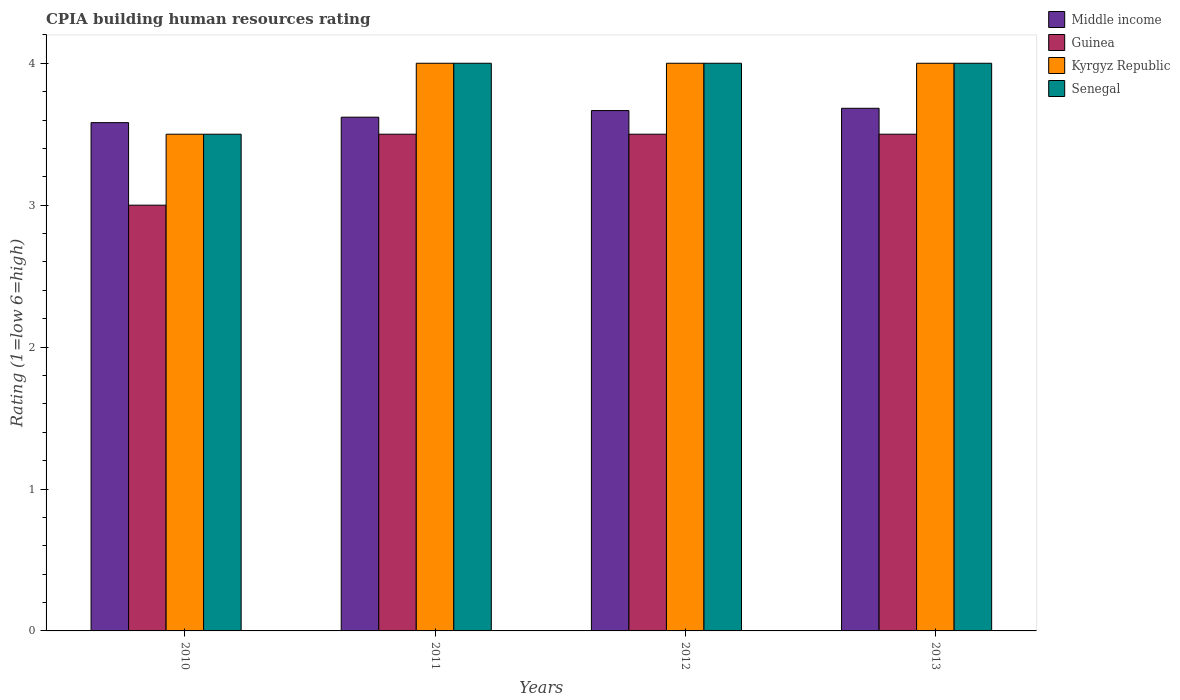How many different coloured bars are there?
Ensure brevity in your answer.  4. How many groups of bars are there?
Ensure brevity in your answer.  4. Are the number of bars on each tick of the X-axis equal?
Keep it short and to the point. Yes. How many bars are there on the 1st tick from the left?
Provide a short and direct response. 4. How many bars are there on the 2nd tick from the right?
Offer a terse response. 4. In how many cases, is the number of bars for a given year not equal to the number of legend labels?
Provide a succinct answer. 0. What is the CPIA rating in Senegal in 2011?
Offer a terse response. 4. Across all years, what is the minimum CPIA rating in Middle income?
Your response must be concise. 3.58. In which year was the CPIA rating in Middle income maximum?
Your answer should be very brief. 2013. In which year was the CPIA rating in Kyrgyz Republic minimum?
Give a very brief answer. 2010. What is the total CPIA rating in Middle income in the graph?
Provide a succinct answer. 14.55. What is the difference between the CPIA rating in Senegal in 2011 and the CPIA rating in Guinea in 2010?
Your answer should be very brief. 1. What is the average CPIA rating in Middle income per year?
Give a very brief answer. 3.64. In the year 2013, what is the difference between the CPIA rating in Middle income and CPIA rating in Guinea?
Make the answer very short. 0.18. In how many years, is the CPIA rating in Middle income greater than 2.2?
Your answer should be very brief. 4. Is the CPIA rating in Kyrgyz Republic in 2010 less than that in 2011?
Keep it short and to the point. Yes. Is the difference between the CPIA rating in Middle income in 2010 and 2011 greater than the difference between the CPIA rating in Guinea in 2010 and 2011?
Offer a terse response. Yes. What is the difference between the highest and the lowest CPIA rating in Senegal?
Provide a short and direct response. 0.5. In how many years, is the CPIA rating in Kyrgyz Republic greater than the average CPIA rating in Kyrgyz Republic taken over all years?
Your response must be concise. 3. What does the 4th bar from the left in 2010 represents?
Offer a terse response. Senegal. Is it the case that in every year, the sum of the CPIA rating in Middle income and CPIA rating in Kyrgyz Republic is greater than the CPIA rating in Guinea?
Offer a very short reply. Yes. Are all the bars in the graph horizontal?
Your answer should be very brief. No. How many years are there in the graph?
Offer a very short reply. 4. What is the difference between two consecutive major ticks on the Y-axis?
Your response must be concise. 1. How many legend labels are there?
Provide a short and direct response. 4. How are the legend labels stacked?
Your answer should be very brief. Vertical. What is the title of the graph?
Provide a short and direct response. CPIA building human resources rating. Does "Egypt, Arab Rep." appear as one of the legend labels in the graph?
Keep it short and to the point. No. What is the label or title of the X-axis?
Offer a terse response. Years. What is the Rating (1=low 6=high) in Middle income in 2010?
Your answer should be very brief. 3.58. What is the Rating (1=low 6=high) of Guinea in 2010?
Your answer should be compact. 3. What is the Rating (1=low 6=high) of Senegal in 2010?
Provide a succinct answer. 3.5. What is the Rating (1=low 6=high) in Middle income in 2011?
Offer a terse response. 3.62. What is the Rating (1=low 6=high) of Guinea in 2011?
Ensure brevity in your answer.  3.5. What is the Rating (1=low 6=high) of Kyrgyz Republic in 2011?
Your answer should be very brief. 4. What is the Rating (1=low 6=high) in Senegal in 2011?
Your response must be concise. 4. What is the Rating (1=low 6=high) of Middle income in 2012?
Your answer should be compact. 3.67. What is the Rating (1=low 6=high) of Guinea in 2012?
Your answer should be very brief. 3.5. What is the Rating (1=low 6=high) in Kyrgyz Republic in 2012?
Ensure brevity in your answer.  4. What is the Rating (1=low 6=high) in Middle income in 2013?
Give a very brief answer. 3.68. What is the Rating (1=low 6=high) in Guinea in 2013?
Ensure brevity in your answer.  3.5. What is the Rating (1=low 6=high) of Kyrgyz Republic in 2013?
Provide a short and direct response. 4. Across all years, what is the maximum Rating (1=low 6=high) of Middle income?
Make the answer very short. 3.68. Across all years, what is the maximum Rating (1=low 6=high) in Guinea?
Your response must be concise. 3.5. Across all years, what is the maximum Rating (1=low 6=high) of Senegal?
Provide a succinct answer. 4. Across all years, what is the minimum Rating (1=low 6=high) in Middle income?
Offer a terse response. 3.58. Across all years, what is the minimum Rating (1=low 6=high) in Kyrgyz Republic?
Make the answer very short. 3.5. Across all years, what is the minimum Rating (1=low 6=high) of Senegal?
Your answer should be compact. 3.5. What is the total Rating (1=low 6=high) in Middle income in the graph?
Make the answer very short. 14.55. What is the total Rating (1=low 6=high) in Senegal in the graph?
Your response must be concise. 15.5. What is the difference between the Rating (1=low 6=high) of Middle income in 2010 and that in 2011?
Make the answer very short. -0.04. What is the difference between the Rating (1=low 6=high) of Guinea in 2010 and that in 2011?
Keep it short and to the point. -0.5. What is the difference between the Rating (1=low 6=high) of Kyrgyz Republic in 2010 and that in 2011?
Keep it short and to the point. -0.5. What is the difference between the Rating (1=low 6=high) in Senegal in 2010 and that in 2011?
Offer a very short reply. -0.5. What is the difference between the Rating (1=low 6=high) in Middle income in 2010 and that in 2012?
Ensure brevity in your answer.  -0.09. What is the difference between the Rating (1=low 6=high) of Kyrgyz Republic in 2010 and that in 2012?
Ensure brevity in your answer.  -0.5. What is the difference between the Rating (1=low 6=high) in Middle income in 2010 and that in 2013?
Provide a short and direct response. -0.1. What is the difference between the Rating (1=low 6=high) in Kyrgyz Republic in 2010 and that in 2013?
Make the answer very short. -0.5. What is the difference between the Rating (1=low 6=high) in Senegal in 2010 and that in 2013?
Offer a terse response. -0.5. What is the difference between the Rating (1=low 6=high) of Middle income in 2011 and that in 2012?
Offer a very short reply. -0.05. What is the difference between the Rating (1=low 6=high) of Kyrgyz Republic in 2011 and that in 2012?
Make the answer very short. 0. What is the difference between the Rating (1=low 6=high) in Middle income in 2011 and that in 2013?
Make the answer very short. -0.06. What is the difference between the Rating (1=low 6=high) of Kyrgyz Republic in 2011 and that in 2013?
Ensure brevity in your answer.  0. What is the difference between the Rating (1=low 6=high) in Senegal in 2011 and that in 2013?
Keep it short and to the point. 0. What is the difference between the Rating (1=low 6=high) of Middle income in 2012 and that in 2013?
Keep it short and to the point. -0.02. What is the difference between the Rating (1=low 6=high) of Guinea in 2012 and that in 2013?
Your answer should be very brief. 0. What is the difference between the Rating (1=low 6=high) in Middle income in 2010 and the Rating (1=low 6=high) in Guinea in 2011?
Your response must be concise. 0.08. What is the difference between the Rating (1=low 6=high) in Middle income in 2010 and the Rating (1=low 6=high) in Kyrgyz Republic in 2011?
Your answer should be very brief. -0.42. What is the difference between the Rating (1=low 6=high) in Middle income in 2010 and the Rating (1=low 6=high) in Senegal in 2011?
Keep it short and to the point. -0.42. What is the difference between the Rating (1=low 6=high) of Guinea in 2010 and the Rating (1=low 6=high) of Senegal in 2011?
Make the answer very short. -1. What is the difference between the Rating (1=low 6=high) of Middle income in 2010 and the Rating (1=low 6=high) of Guinea in 2012?
Offer a terse response. 0.08. What is the difference between the Rating (1=low 6=high) of Middle income in 2010 and the Rating (1=low 6=high) of Kyrgyz Republic in 2012?
Make the answer very short. -0.42. What is the difference between the Rating (1=low 6=high) in Middle income in 2010 and the Rating (1=low 6=high) in Senegal in 2012?
Ensure brevity in your answer.  -0.42. What is the difference between the Rating (1=low 6=high) of Guinea in 2010 and the Rating (1=low 6=high) of Senegal in 2012?
Keep it short and to the point. -1. What is the difference between the Rating (1=low 6=high) in Kyrgyz Republic in 2010 and the Rating (1=low 6=high) in Senegal in 2012?
Give a very brief answer. -0.5. What is the difference between the Rating (1=low 6=high) of Middle income in 2010 and the Rating (1=low 6=high) of Guinea in 2013?
Give a very brief answer. 0.08. What is the difference between the Rating (1=low 6=high) in Middle income in 2010 and the Rating (1=low 6=high) in Kyrgyz Republic in 2013?
Make the answer very short. -0.42. What is the difference between the Rating (1=low 6=high) of Middle income in 2010 and the Rating (1=low 6=high) of Senegal in 2013?
Your answer should be compact. -0.42. What is the difference between the Rating (1=low 6=high) of Guinea in 2010 and the Rating (1=low 6=high) of Kyrgyz Republic in 2013?
Your response must be concise. -1. What is the difference between the Rating (1=low 6=high) in Middle income in 2011 and the Rating (1=low 6=high) in Guinea in 2012?
Your response must be concise. 0.12. What is the difference between the Rating (1=low 6=high) of Middle income in 2011 and the Rating (1=low 6=high) of Kyrgyz Republic in 2012?
Offer a terse response. -0.38. What is the difference between the Rating (1=low 6=high) of Middle income in 2011 and the Rating (1=low 6=high) of Senegal in 2012?
Ensure brevity in your answer.  -0.38. What is the difference between the Rating (1=low 6=high) of Guinea in 2011 and the Rating (1=low 6=high) of Kyrgyz Republic in 2012?
Provide a succinct answer. -0.5. What is the difference between the Rating (1=low 6=high) of Middle income in 2011 and the Rating (1=low 6=high) of Guinea in 2013?
Keep it short and to the point. 0.12. What is the difference between the Rating (1=low 6=high) of Middle income in 2011 and the Rating (1=low 6=high) of Kyrgyz Republic in 2013?
Ensure brevity in your answer.  -0.38. What is the difference between the Rating (1=low 6=high) in Middle income in 2011 and the Rating (1=low 6=high) in Senegal in 2013?
Offer a terse response. -0.38. What is the difference between the Rating (1=low 6=high) in Guinea in 2011 and the Rating (1=low 6=high) in Kyrgyz Republic in 2013?
Your answer should be compact. -0.5. What is the difference between the Rating (1=low 6=high) of Middle income in 2012 and the Rating (1=low 6=high) of Kyrgyz Republic in 2013?
Provide a short and direct response. -0.33. What is the difference between the Rating (1=low 6=high) of Guinea in 2012 and the Rating (1=low 6=high) of Kyrgyz Republic in 2013?
Your answer should be compact. -0.5. What is the difference between the Rating (1=low 6=high) of Guinea in 2012 and the Rating (1=low 6=high) of Senegal in 2013?
Ensure brevity in your answer.  -0.5. What is the difference between the Rating (1=low 6=high) in Kyrgyz Republic in 2012 and the Rating (1=low 6=high) in Senegal in 2013?
Provide a succinct answer. 0. What is the average Rating (1=low 6=high) in Middle income per year?
Make the answer very short. 3.64. What is the average Rating (1=low 6=high) of Guinea per year?
Your answer should be very brief. 3.38. What is the average Rating (1=low 6=high) of Kyrgyz Republic per year?
Make the answer very short. 3.88. What is the average Rating (1=low 6=high) of Senegal per year?
Provide a short and direct response. 3.88. In the year 2010, what is the difference between the Rating (1=low 6=high) in Middle income and Rating (1=low 6=high) in Guinea?
Keep it short and to the point. 0.58. In the year 2010, what is the difference between the Rating (1=low 6=high) of Middle income and Rating (1=low 6=high) of Kyrgyz Republic?
Provide a short and direct response. 0.08. In the year 2010, what is the difference between the Rating (1=low 6=high) of Middle income and Rating (1=low 6=high) of Senegal?
Keep it short and to the point. 0.08. In the year 2011, what is the difference between the Rating (1=low 6=high) of Middle income and Rating (1=low 6=high) of Guinea?
Provide a short and direct response. 0.12. In the year 2011, what is the difference between the Rating (1=low 6=high) in Middle income and Rating (1=low 6=high) in Kyrgyz Republic?
Your response must be concise. -0.38. In the year 2011, what is the difference between the Rating (1=low 6=high) of Middle income and Rating (1=low 6=high) of Senegal?
Offer a terse response. -0.38. In the year 2011, what is the difference between the Rating (1=low 6=high) in Guinea and Rating (1=low 6=high) in Kyrgyz Republic?
Keep it short and to the point. -0.5. In the year 2011, what is the difference between the Rating (1=low 6=high) in Kyrgyz Republic and Rating (1=low 6=high) in Senegal?
Ensure brevity in your answer.  0. In the year 2012, what is the difference between the Rating (1=low 6=high) in Middle income and Rating (1=low 6=high) in Guinea?
Give a very brief answer. 0.17. In the year 2012, what is the difference between the Rating (1=low 6=high) of Middle income and Rating (1=low 6=high) of Senegal?
Provide a succinct answer. -0.33. In the year 2012, what is the difference between the Rating (1=low 6=high) of Guinea and Rating (1=low 6=high) of Kyrgyz Republic?
Make the answer very short. -0.5. In the year 2013, what is the difference between the Rating (1=low 6=high) in Middle income and Rating (1=low 6=high) in Guinea?
Your answer should be compact. 0.18. In the year 2013, what is the difference between the Rating (1=low 6=high) in Middle income and Rating (1=low 6=high) in Kyrgyz Republic?
Give a very brief answer. -0.32. In the year 2013, what is the difference between the Rating (1=low 6=high) of Middle income and Rating (1=low 6=high) of Senegal?
Your answer should be compact. -0.32. In the year 2013, what is the difference between the Rating (1=low 6=high) of Guinea and Rating (1=low 6=high) of Kyrgyz Republic?
Your answer should be compact. -0.5. In the year 2013, what is the difference between the Rating (1=low 6=high) of Kyrgyz Republic and Rating (1=low 6=high) of Senegal?
Ensure brevity in your answer.  0. What is the ratio of the Rating (1=low 6=high) in Kyrgyz Republic in 2010 to that in 2011?
Offer a very short reply. 0.88. What is the ratio of the Rating (1=low 6=high) in Middle income in 2010 to that in 2012?
Your answer should be compact. 0.98. What is the ratio of the Rating (1=low 6=high) of Guinea in 2010 to that in 2012?
Provide a succinct answer. 0.86. What is the ratio of the Rating (1=low 6=high) in Kyrgyz Republic in 2010 to that in 2012?
Ensure brevity in your answer.  0.88. What is the ratio of the Rating (1=low 6=high) in Senegal in 2010 to that in 2012?
Offer a very short reply. 0.88. What is the ratio of the Rating (1=low 6=high) of Middle income in 2010 to that in 2013?
Give a very brief answer. 0.97. What is the ratio of the Rating (1=low 6=high) in Kyrgyz Republic in 2010 to that in 2013?
Offer a terse response. 0.88. What is the ratio of the Rating (1=low 6=high) in Middle income in 2011 to that in 2012?
Your answer should be compact. 0.99. What is the ratio of the Rating (1=low 6=high) of Guinea in 2011 to that in 2012?
Offer a terse response. 1. What is the ratio of the Rating (1=low 6=high) of Middle income in 2011 to that in 2013?
Your answer should be very brief. 0.98. What is the ratio of the Rating (1=low 6=high) of Guinea in 2011 to that in 2013?
Your response must be concise. 1. What is the ratio of the Rating (1=low 6=high) of Kyrgyz Republic in 2011 to that in 2013?
Offer a terse response. 1. What is the difference between the highest and the second highest Rating (1=low 6=high) in Middle income?
Provide a succinct answer. 0.02. What is the difference between the highest and the second highest Rating (1=low 6=high) in Guinea?
Give a very brief answer. 0. What is the difference between the highest and the lowest Rating (1=low 6=high) in Middle income?
Provide a short and direct response. 0.1. What is the difference between the highest and the lowest Rating (1=low 6=high) of Guinea?
Your answer should be very brief. 0.5. What is the difference between the highest and the lowest Rating (1=low 6=high) in Kyrgyz Republic?
Make the answer very short. 0.5. What is the difference between the highest and the lowest Rating (1=low 6=high) of Senegal?
Ensure brevity in your answer.  0.5. 